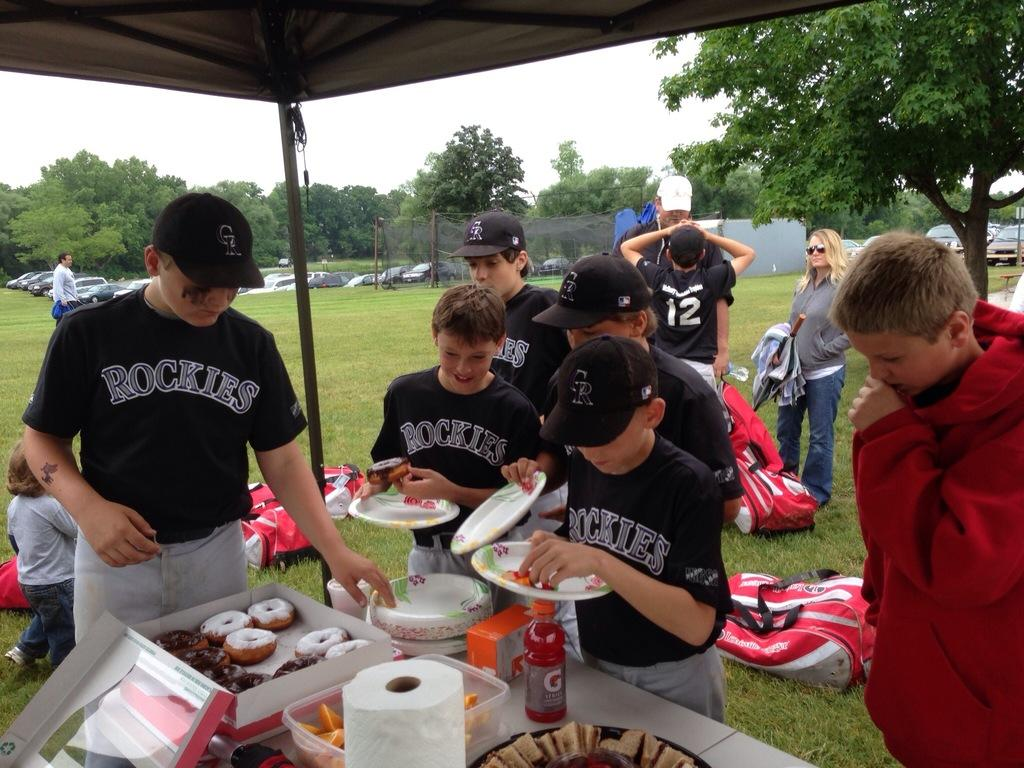<image>
Describe the image concisely. A group of kids wearing "Rockies" jerseys are in line to get food. 